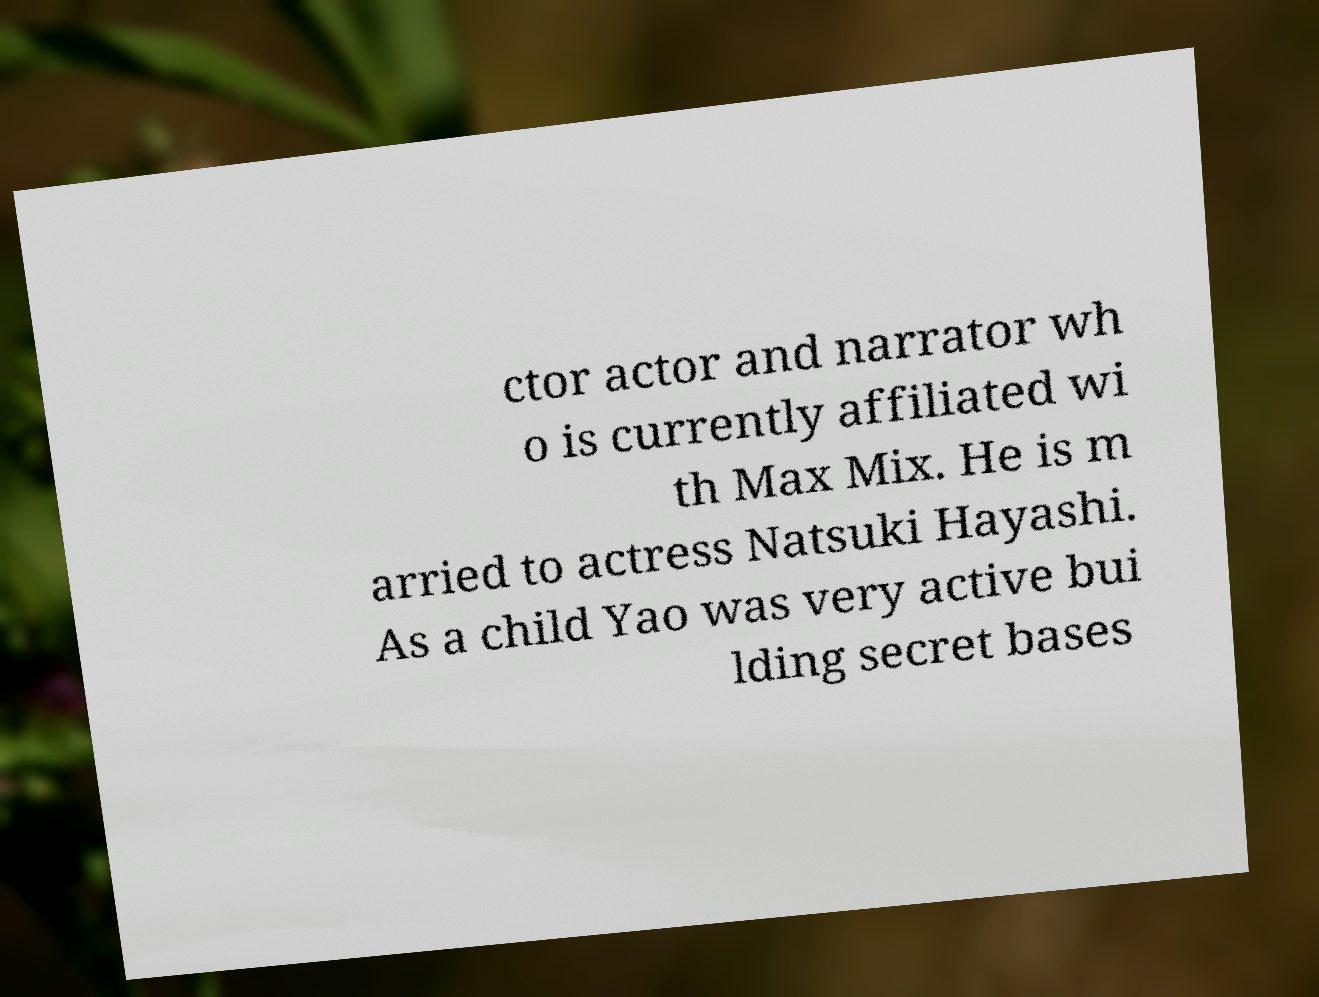Please identify and transcribe the text found in this image. ctor actor and narrator wh o is currently affiliated wi th Max Mix. He is m arried to actress Natsuki Hayashi. As a child Yao was very active bui lding secret bases 